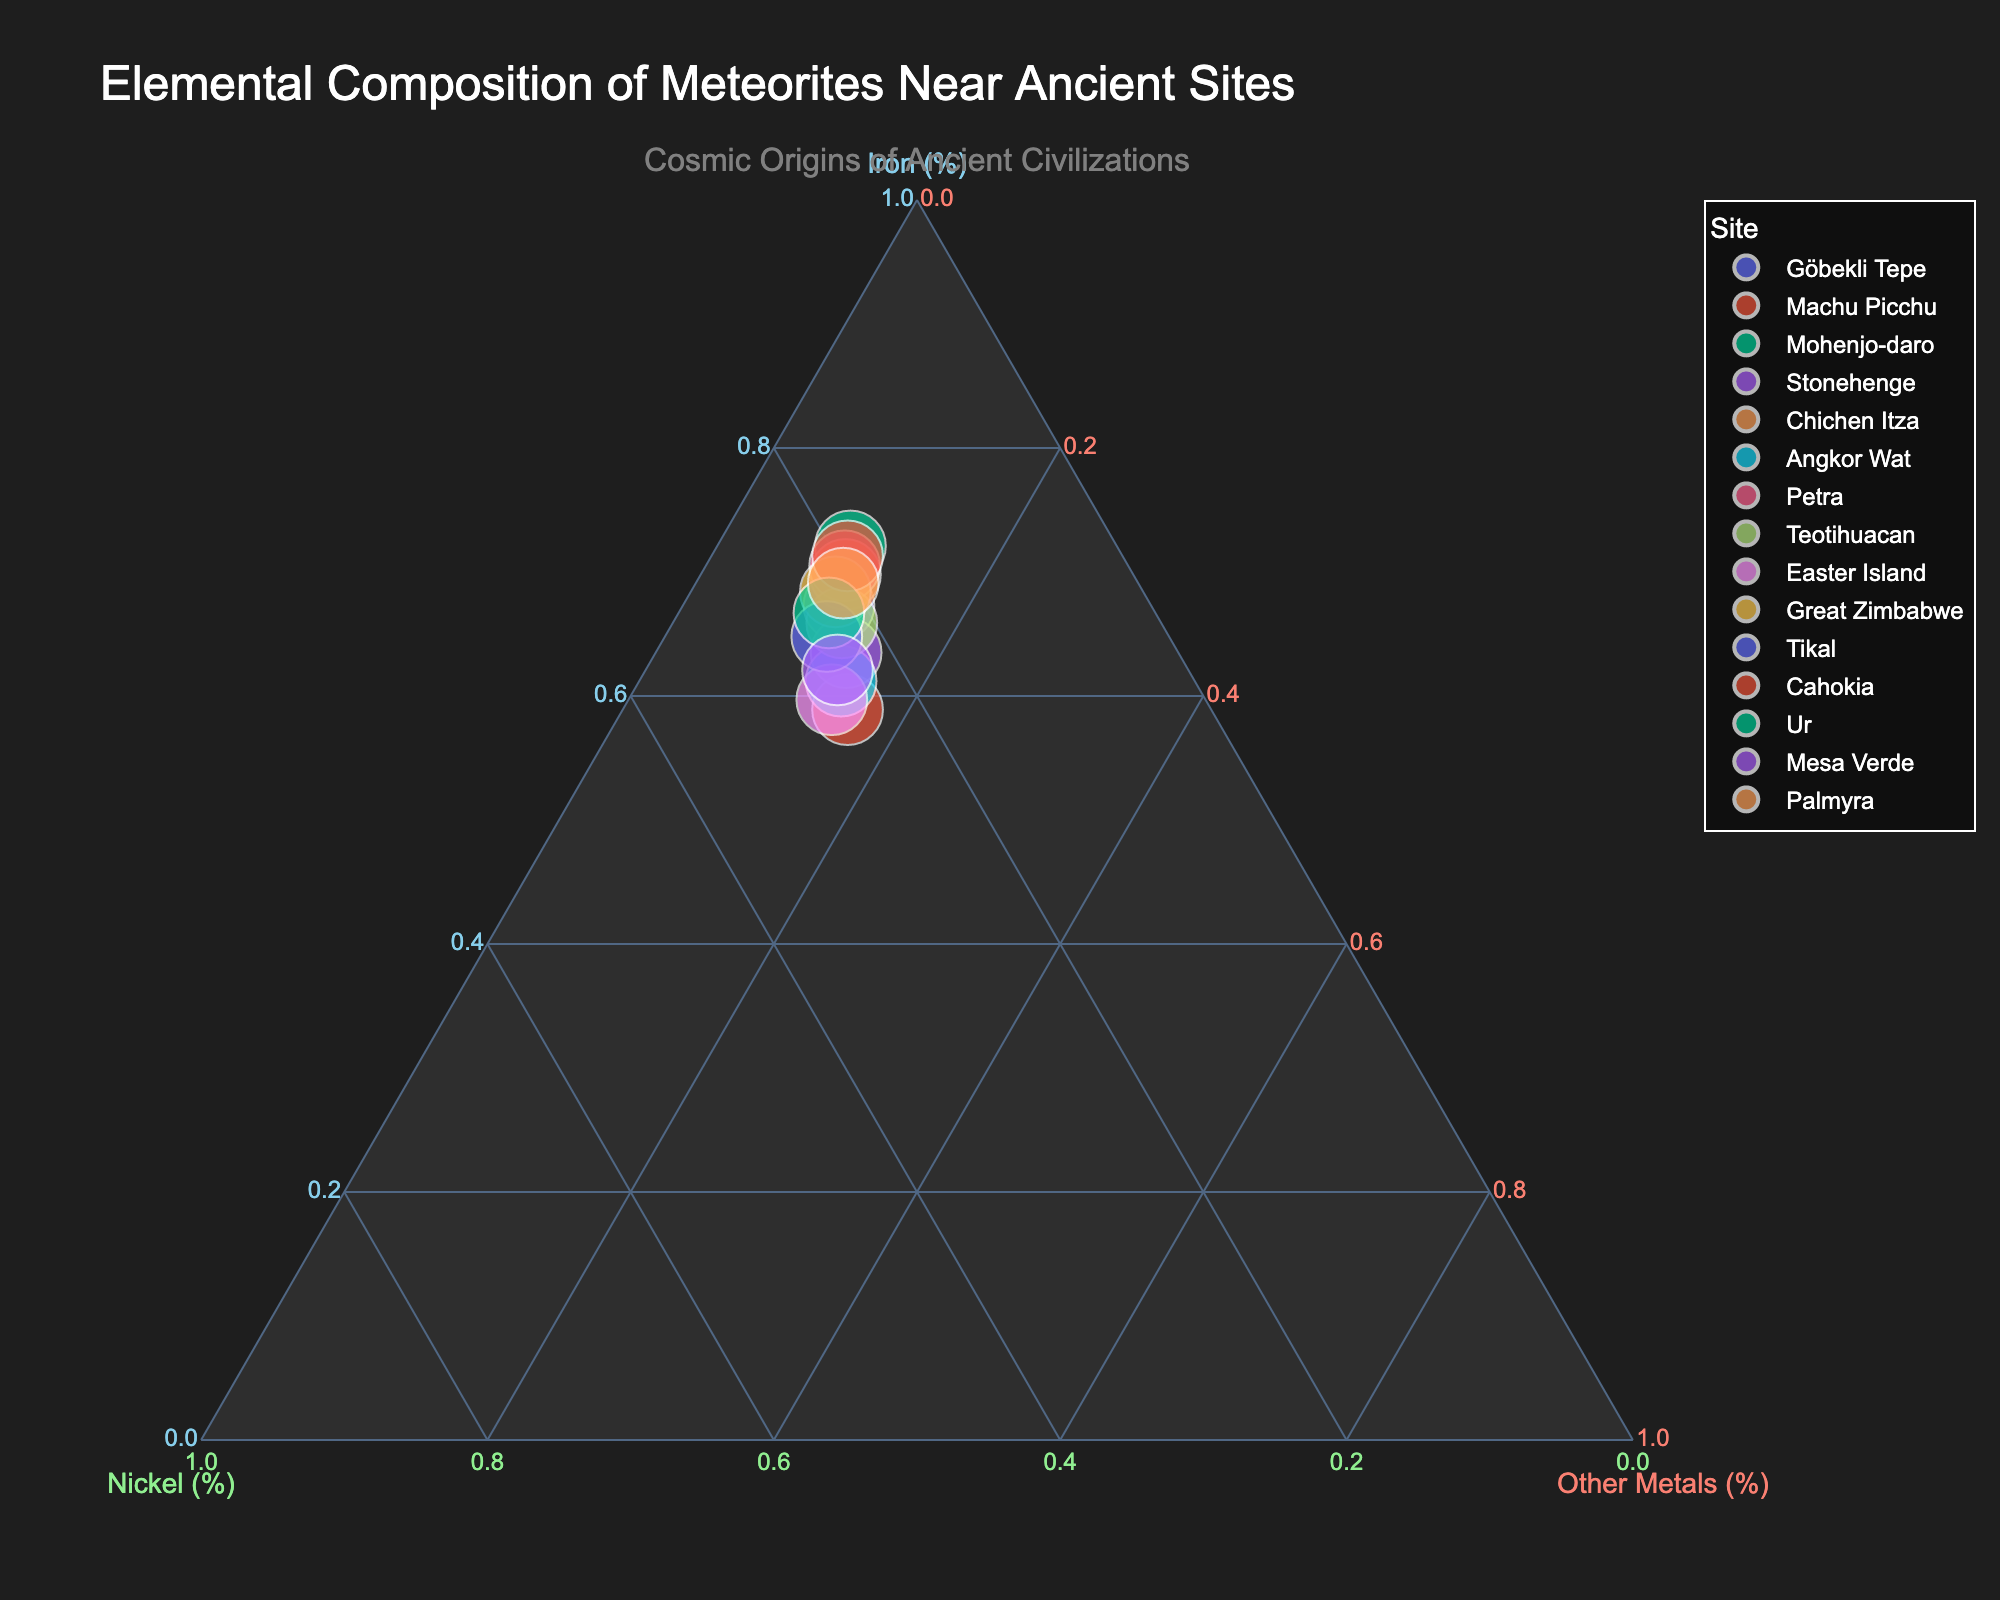What is the title of the figure? The title is prominently displayed at the top of the figure.
Answer: Elemental Composition of Meteorites Near Ancient Sites How many ancient sites are represented in the plot? There is one distinct color for each site; counting the number of unique colors gives the answer.
Answer: 15 Which site has the highest iron content? By locating the site closest to the "Iron (%)" axis on the plot, we identify the one with the highest iron content.
Answer: Mohenjo-daro Which site has the highest nickel content? By identifying the site closest to the "Nickel (%)" axis on the plot, we determine which has the highest nickel content.
Answer: Easter Island What site is closest to having equal parts Iron, Nickel, and Other Metals? Look for the point nearest the center of the ternary plot where all three axes meet.
Answer: Machu Picchu What range of values do the iron percentages cover in the plot? Observe the minimum and maximum values on the "Iron (%)" axis for all data points.
Answer: 58.9% to 72.1% Compare Machu Picchu and Stonehenge based on their Nickel content. Which has more? Find the positions of Machu Picchu and Stonehenge on the "Nickel (%)" axis and see which is higher.
Answer: Stonehenge What is the total elemental composition of the meteorite for the site Chichen Itza? Since the sizes of the points represent the total composition and each is normalized to 100%, we sum Iron, Nickel, and Other Metals for Chichen Itza.
Answer: 100% Among Göbekli Tepe, Petra, and Cahokia, which site has the lowest Other Metals content? Compare the positions of Göbekli Tepe, Petra, and Cahokia on the "Other Metals (%)" axis and look for the smallest value.
Answer: Cahokia Which site has a similar combination of elemental compositions to Teotihuacan? Look for the site closest to Teotihuacan on the ternary plot, indicating a similar elemental composition.
Answer: Tikal 